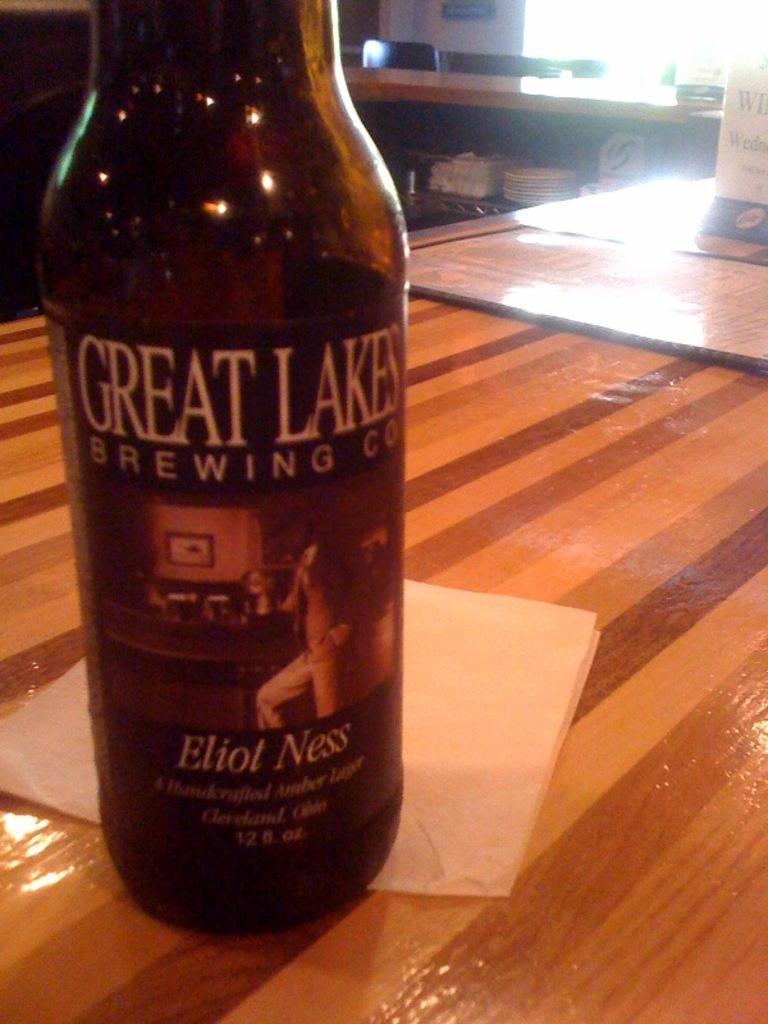<image>
Relay a brief, clear account of the picture shown. A bottle of Great Lakes Brewing Company beer sits on a table. 